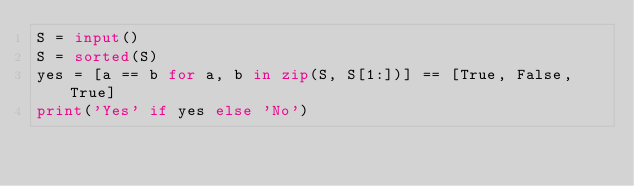<code> <loc_0><loc_0><loc_500><loc_500><_Python_>S = input()
S = sorted(S)
yes = [a == b for a, b in zip(S, S[1:])] == [True, False, True]
print('Yes' if yes else 'No')
</code> 